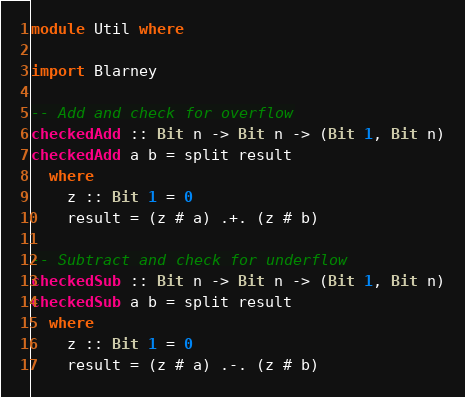<code> <loc_0><loc_0><loc_500><loc_500><_Haskell_>module Util where

import Blarney

-- Add and check for overflow
checkedAdd :: Bit n -> Bit n -> (Bit 1, Bit n)
checkedAdd a b = split result
  where
    z :: Bit 1 = 0
    result = (z # a) .+. (z # b)

-- Subtract and check for underflow
checkedSub :: Bit n -> Bit n -> (Bit 1, Bit n)
checkedSub a b = split result
  where
    z :: Bit 1 = 0
    result = (z # a) .-. (z # b)
</code> 